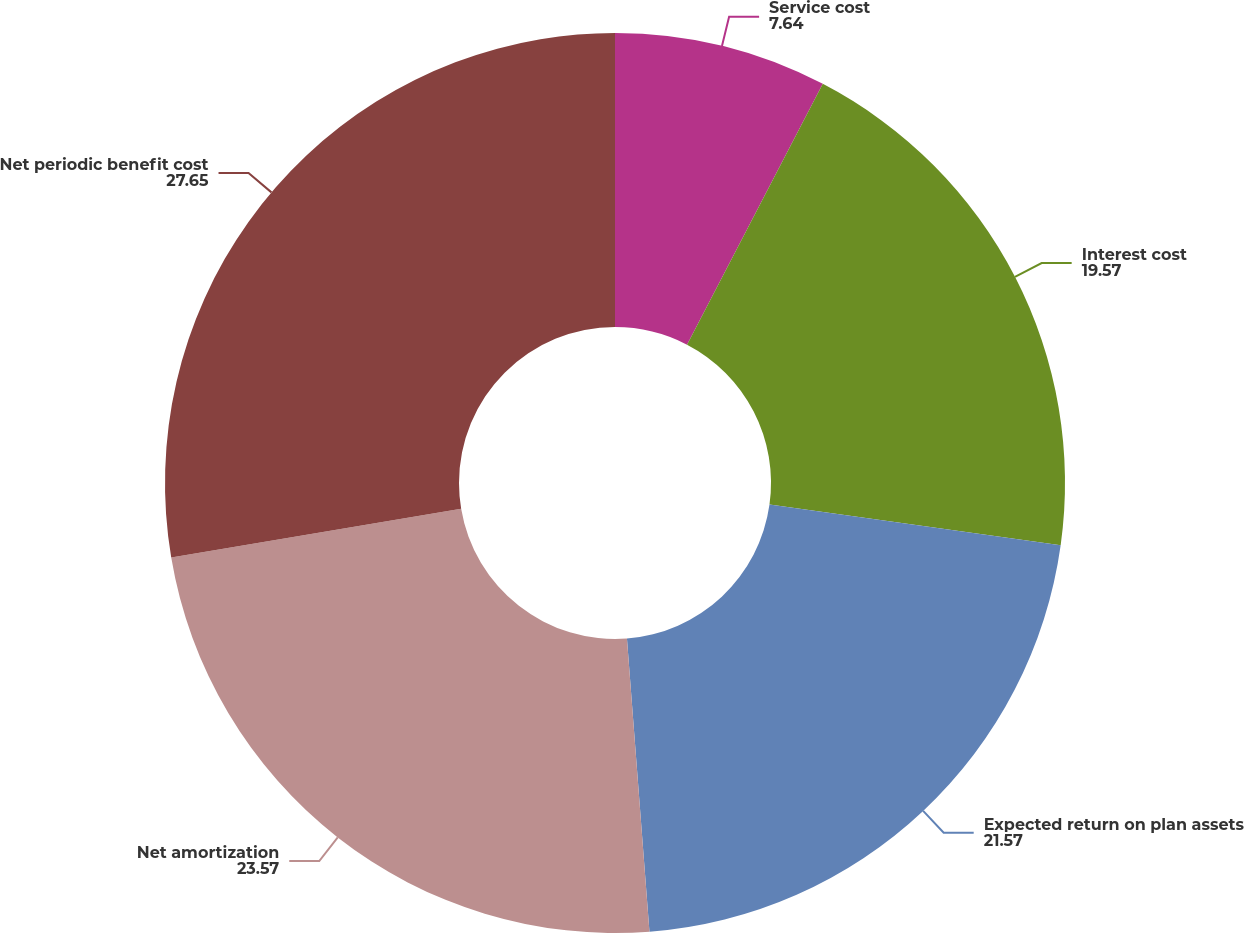<chart> <loc_0><loc_0><loc_500><loc_500><pie_chart><fcel>Service cost<fcel>Interest cost<fcel>Expected return on plan assets<fcel>Net amortization<fcel>Net periodic benefit cost<nl><fcel>7.64%<fcel>19.57%<fcel>21.57%<fcel>23.57%<fcel>27.65%<nl></chart> 